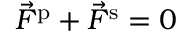<formula> <loc_0><loc_0><loc_500><loc_500>\vec { F } ^ { p } + \vec { F } ^ { s } = 0</formula> 